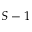Convert formula to latex. <formula><loc_0><loc_0><loc_500><loc_500>S - 1</formula> 